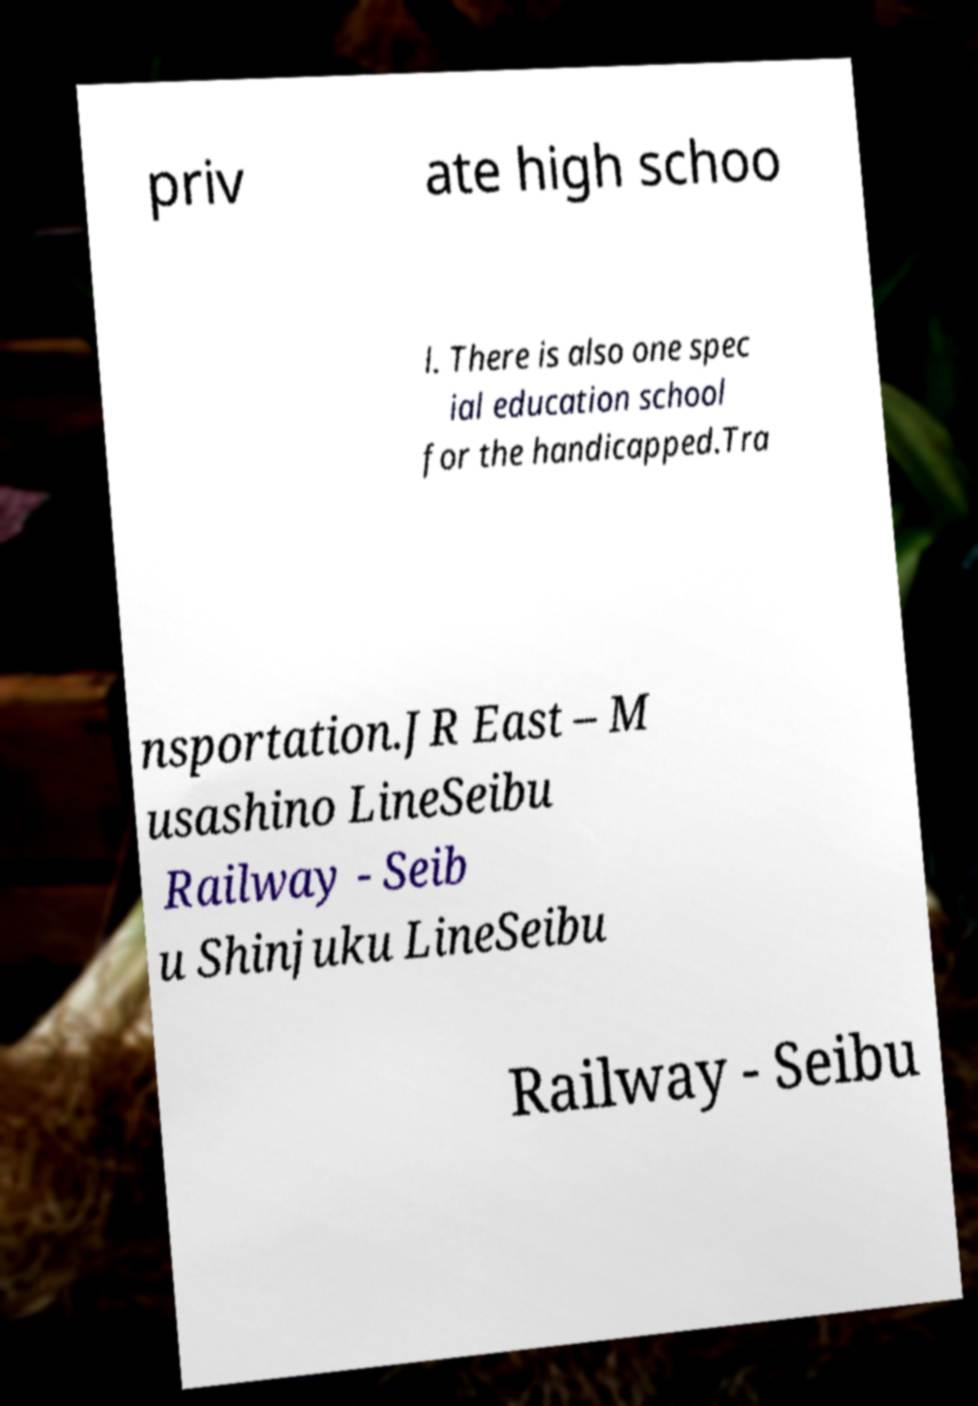There's text embedded in this image that I need extracted. Can you transcribe it verbatim? priv ate high schoo l. There is also one spec ial education school for the handicapped.Tra nsportation.JR East – M usashino LineSeibu Railway - Seib u Shinjuku LineSeibu Railway - Seibu 